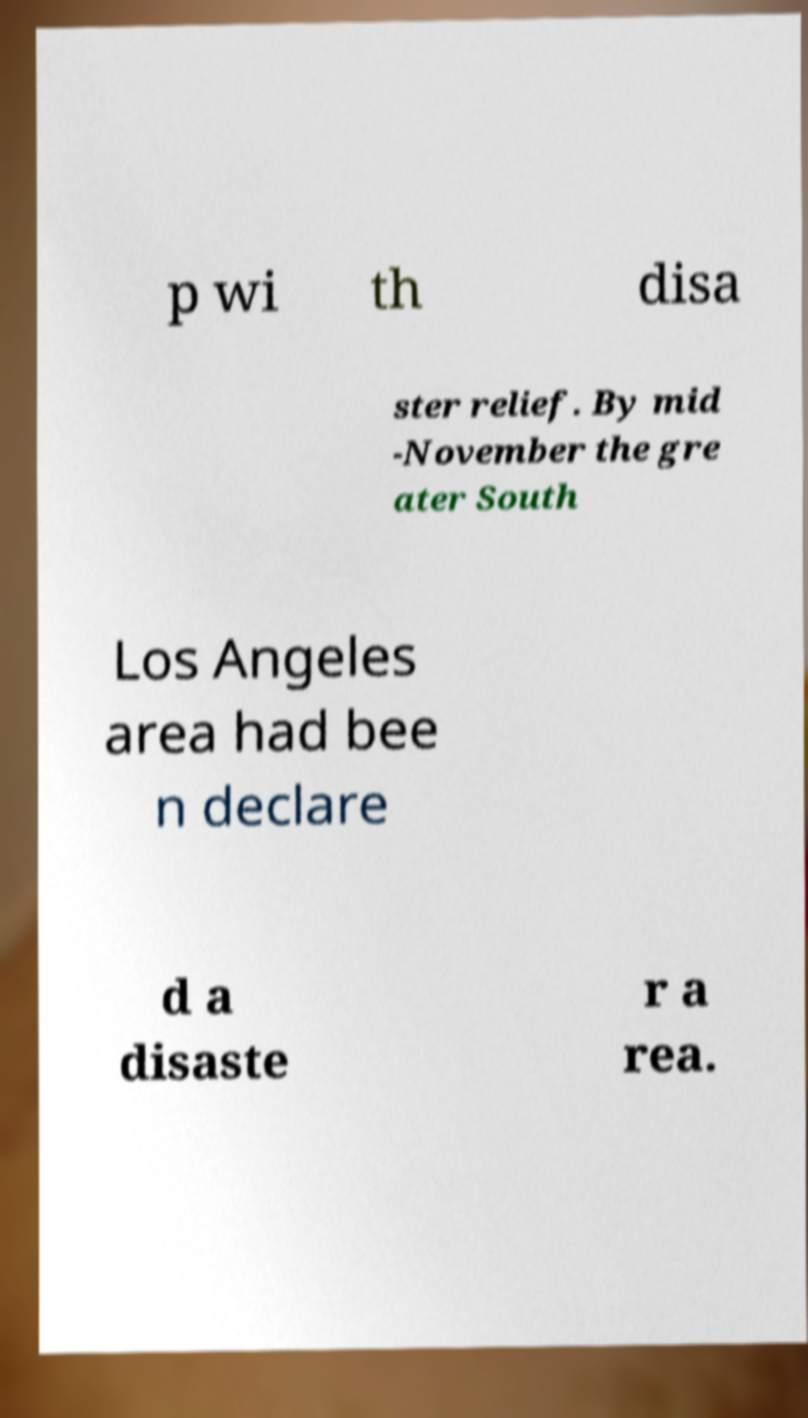Can you read and provide the text displayed in the image?This photo seems to have some interesting text. Can you extract and type it out for me? p wi th disa ster relief. By mid -November the gre ater South Los Angeles area had bee n declare d a disaste r a rea. 